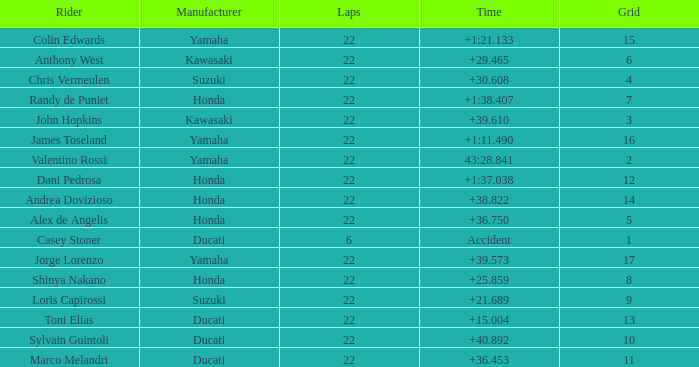Help me parse the entirety of this table. {'header': ['Rider', 'Manufacturer', 'Laps', 'Time', 'Grid'], 'rows': [['Colin Edwards', 'Yamaha', '22', '+1:21.133', '15'], ['Anthony West', 'Kawasaki', '22', '+29.465', '6'], ['Chris Vermeulen', 'Suzuki', '22', '+30.608', '4'], ['Randy de Puniet', 'Honda', '22', '+1:38.407', '7'], ['John Hopkins', 'Kawasaki', '22', '+39.610', '3'], ['James Toseland', 'Yamaha', '22', '+1:11.490', '16'], ['Valentino Rossi', 'Yamaha', '22', '43:28.841', '2'], ['Dani Pedrosa', 'Honda', '22', '+1:37.038', '12'], ['Andrea Dovizioso', 'Honda', '22', '+38.822', '14'], ['Alex de Angelis', 'Honda', '22', '+36.750', '5'], ['Casey Stoner', 'Ducati', '6', 'Accident', '1'], ['Jorge Lorenzo', 'Yamaha', '22', '+39.573', '17'], ['Shinya Nakano', 'Honda', '22', '+25.859', '8'], ['Loris Capirossi', 'Suzuki', '22', '+21.689', '9'], ['Toni Elias', 'Ducati', '22', '+15.004', '13'], ['Sylvain Guintoli', 'Ducati', '22', '+40.892', '10'], ['Marco Melandri', 'Ducati', '22', '+36.453', '11']]} What grid is Ducati with fewer than 22 laps? 1.0. 